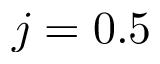<formula> <loc_0><loc_0><loc_500><loc_500>j = 0 . 5</formula> 